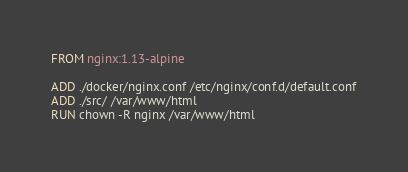Convert code to text. <code><loc_0><loc_0><loc_500><loc_500><_Dockerfile_>FROM nginx:1.13-alpine

ADD ./docker/nginx.conf /etc/nginx/conf.d/default.conf
ADD ./src/ /var/www/html
RUN chown -R nginx /var/www/html</code> 